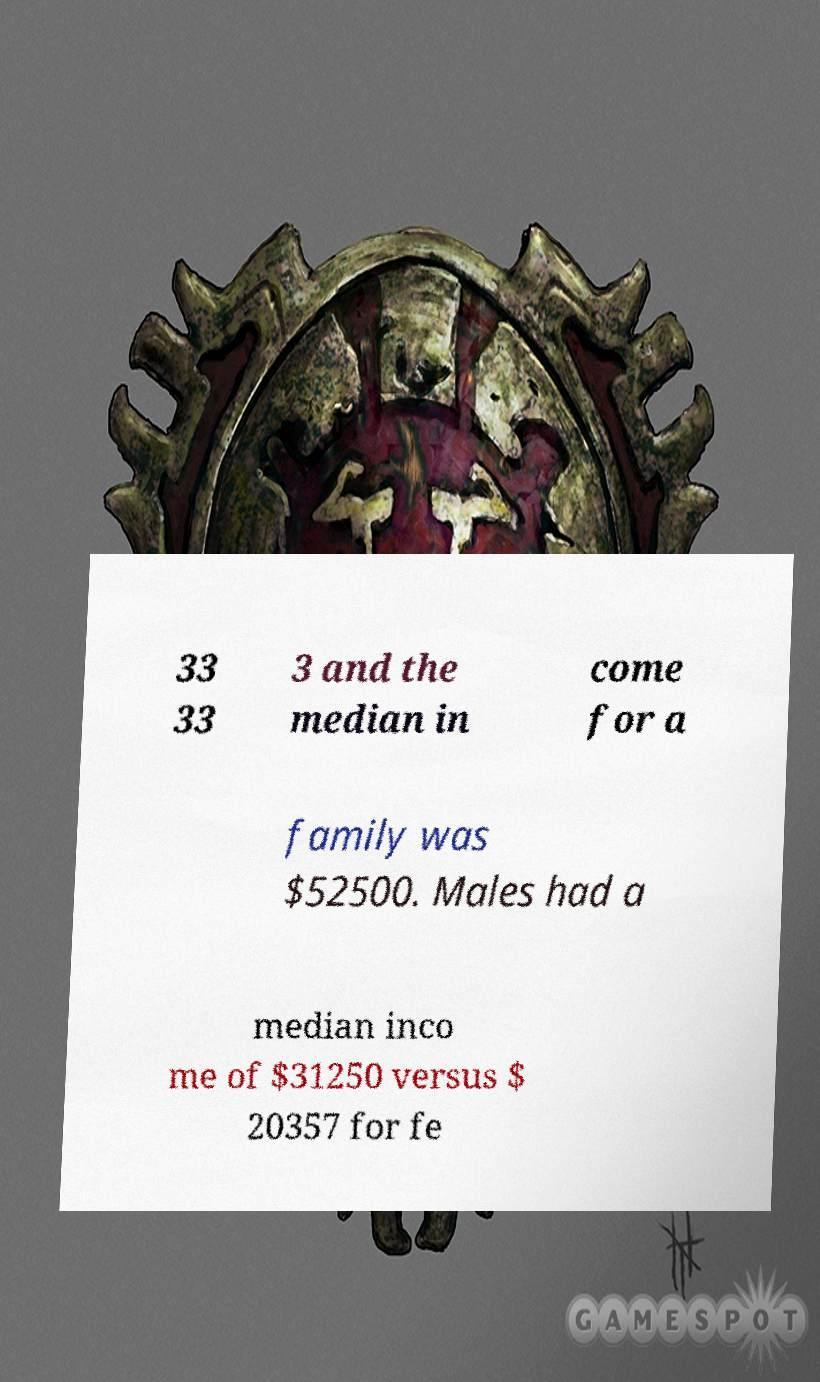Could you assist in decoding the text presented in this image and type it out clearly? 33 33 3 and the median in come for a family was $52500. Males had a median inco me of $31250 versus $ 20357 for fe 